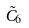Convert formula to latex. <formula><loc_0><loc_0><loc_500><loc_500>\tilde { C } _ { 6 }</formula> 